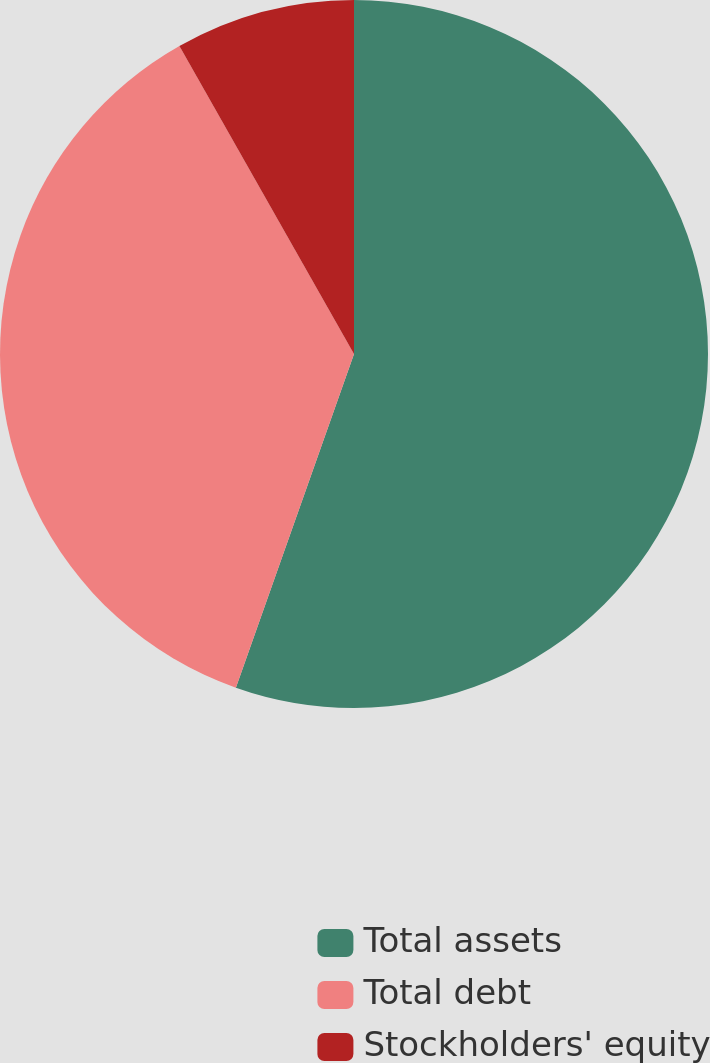<chart> <loc_0><loc_0><loc_500><loc_500><pie_chart><fcel>Total assets<fcel>Total debt<fcel>Stockholders' equity<nl><fcel>55.42%<fcel>36.38%<fcel>8.21%<nl></chart> 